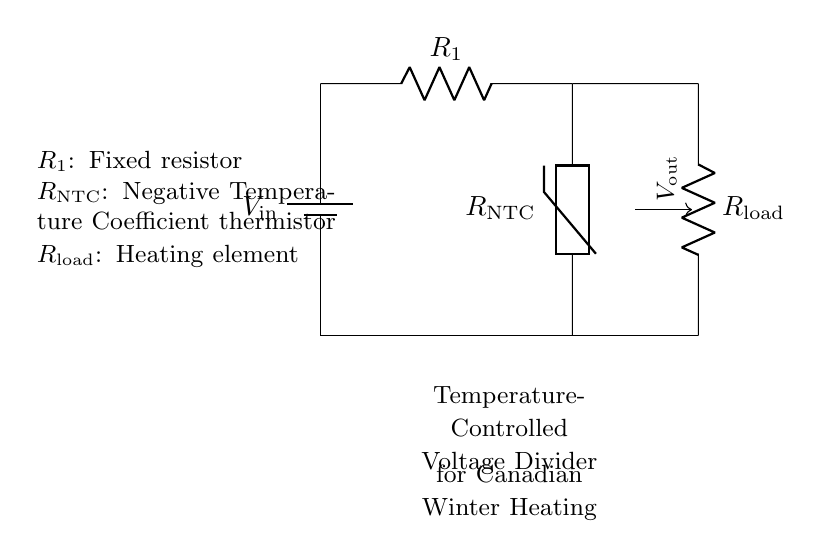What type of thermistor is used in the circuit? The circuit uses a Negative Temperature Coefficient thermistor, indicated by the label $R_\text{NTC}$. This type of thermistor decreases its resistance as temperature increases.
Answer: Negative Temperature Coefficient What is the role of $R_1$ in the circuit? The resistor $R_1$ acts as a fixed resistor to set a reference voltage in conjunction with the thermistor $R_\text{NTC}$. It helps to form the voltage divider necessary for regulating the voltage output based on temperature changes.
Answer: Fixed resistor What does $V_{out}$ represent in the circuit? The node marked $V_{out}$ indicates the voltage that will be supplied to the heating element $R_\text{load}$, which is controlled by the temperature sensed by the thermistor and the resistor.
Answer: Voltage supplied to load How does increasing temperature affect $R_{NTC}$? As the temperature increases, the resistance of the NTC thermistor decreases. This change will affect the voltage output across the load resistor $R_\text{load}$, allowing for better regulation of heating as needed in colder temperatures.
Answer: Resistance decreases What is the configuration of this circuit? This circuit is a voltage divider configuration because it consists of two resistive elements, $R_1$ and $R_\text{NTC}$, arranged in series, which divides the input voltage based on their resistances.
Answer: Voltage divider What is connected to the output of the voltage divider? The output $V_{out}$ is connected to the heating element, which is denoted as $R_\text{load}$. This setup is designed to control the heating based on the temperature sensed.
Answer: Heating element What happens to $V_{out}$ when the temperature is low? When the temperature is low, the resistance of the NTC thermistor $R_\text{NTC}$ is higher, leading to a higher voltage at $V_{out}$ that is applied to the heating element, increasing the heat output.
Answer: Higher voltage output 